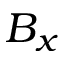Convert formula to latex. <formula><loc_0><loc_0><loc_500><loc_500>B _ { x }</formula> 